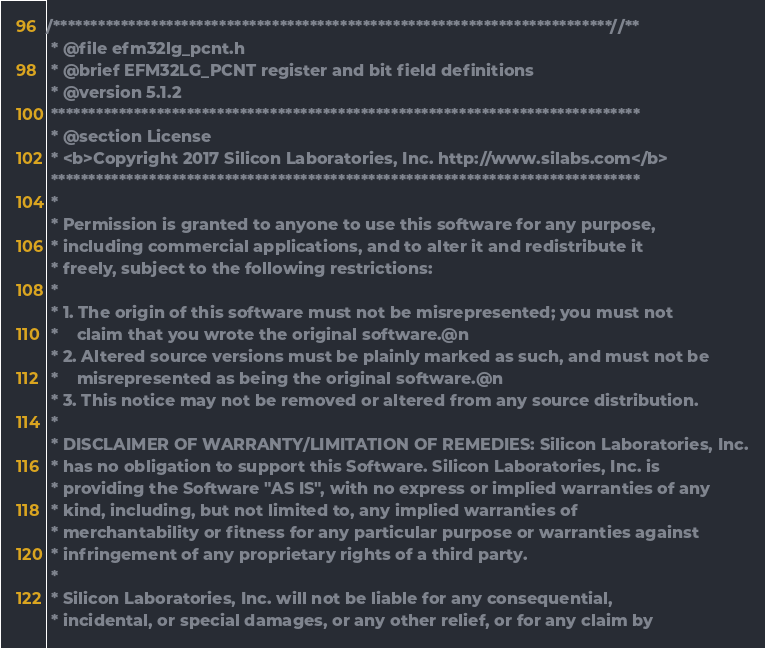<code> <loc_0><loc_0><loc_500><loc_500><_C_>/**************************************************************************//**
 * @file efm32lg_pcnt.h
 * @brief EFM32LG_PCNT register and bit field definitions
 * @version 5.1.2
 ******************************************************************************
 * @section License
 * <b>Copyright 2017 Silicon Laboratories, Inc. http://www.silabs.com</b>
 ******************************************************************************
 *
 * Permission is granted to anyone to use this software for any purpose,
 * including commercial applications, and to alter it and redistribute it
 * freely, subject to the following restrictions:
 *
 * 1. The origin of this software must not be misrepresented; you must not
 *    claim that you wrote the original software.@n
 * 2. Altered source versions must be plainly marked as such, and must not be
 *    misrepresented as being the original software.@n
 * 3. This notice may not be removed or altered from any source distribution.
 *
 * DISCLAIMER OF WARRANTY/LIMITATION OF REMEDIES: Silicon Laboratories, Inc.
 * has no obligation to support this Software. Silicon Laboratories, Inc. is
 * providing the Software "AS IS", with no express or implied warranties of any
 * kind, including, but not limited to, any implied warranties of
 * merchantability or fitness for any particular purpose or warranties against
 * infringement of any proprietary rights of a third party.
 *
 * Silicon Laboratories, Inc. will not be liable for any consequential,
 * incidental, or special damages, or any other relief, or for any claim by</code> 